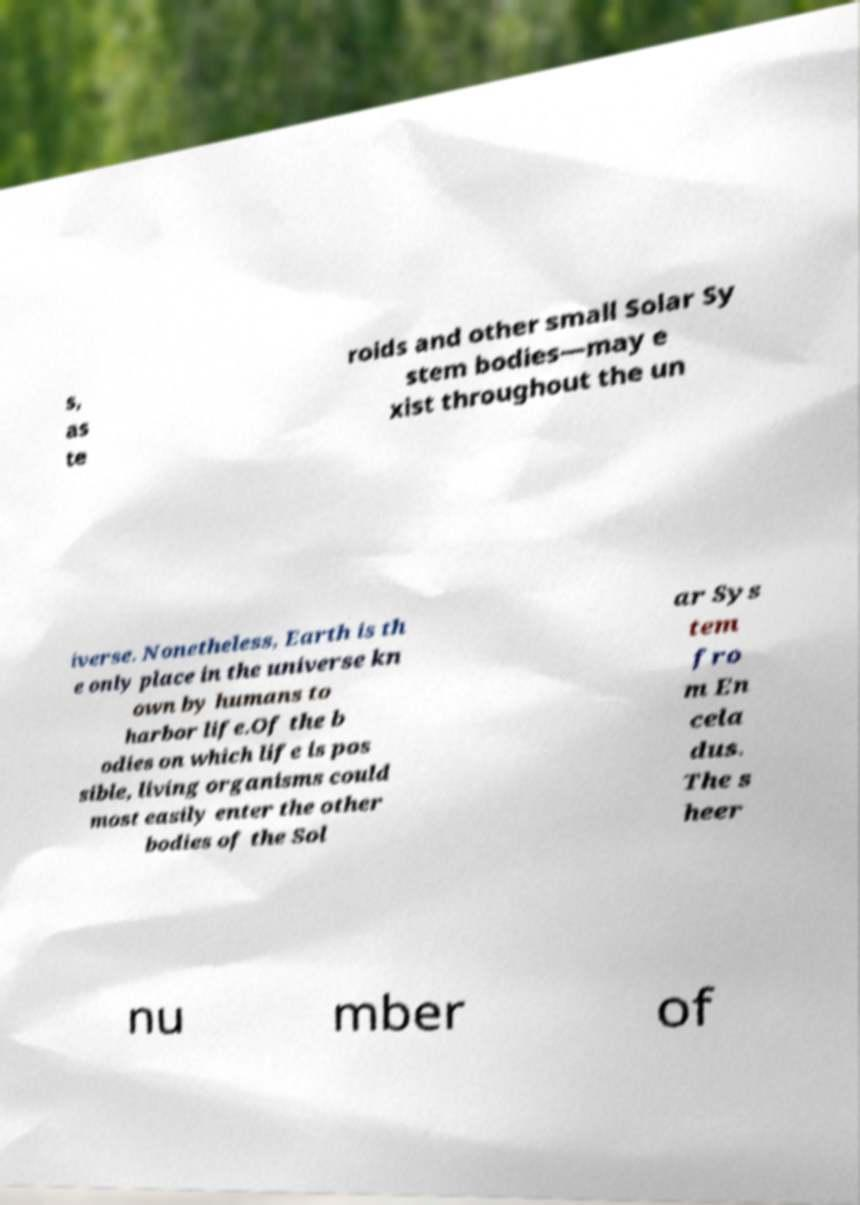Can you accurately transcribe the text from the provided image for me? s, as te roids and other small Solar Sy stem bodies—may e xist throughout the un iverse. Nonetheless, Earth is th e only place in the universe kn own by humans to harbor life.Of the b odies on which life is pos sible, living organisms could most easily enter the other bodies of the Sol ar Sys tem fro m En cela dus. The s heer nu mber of 